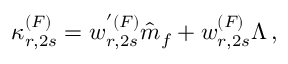<formula> <loc_0><loc_0><loc_500><loc_500>\kappa _ { r , 2 s } ^ { ( F ) } = w _ { r , 2 s } ^ { ^ { \prime } ( F ) } \hat { m } _ { f } + w _ { r , 2 s } ^ { ( F ) } \Lambda \, ,</formula> 